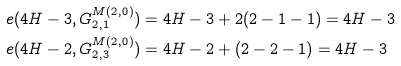<formula> <loc_0><loc_0><loc_500><loc_500>e ( 4 H - 3 , G ^ { M ( 2 , 0 ) } _ { 2 , 1 } ) & = 4 H - 3 + 2 ( 2 - 1 - 1 ) = 4 H - 3 \\ e ( 4 H - 2 , G ^ { M ( 2 , 0 ) } _ { 2 , 3 } ) & = 4 H - 2 + ( 2 - 2 - 1 ) = 4 H - 3</formula> 